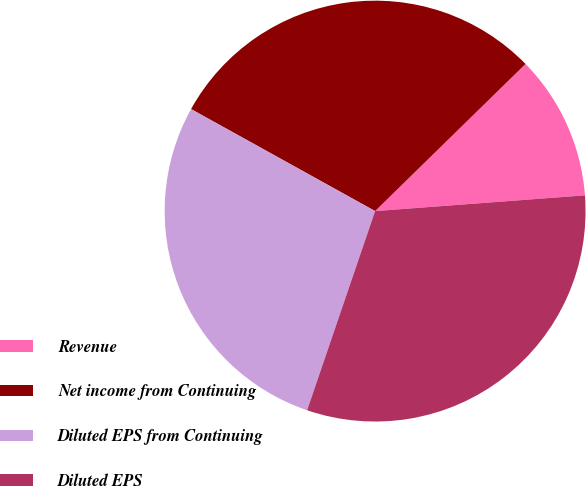<chart> <loc_0><loc_0><loc_500><loc_500><pie_chart><fcel>Revenue<fcel>Net income from Continuing<fcel>Diluted EPS from Continuing<fcel>Diluted EPS<nl><fcel>11.13%<fcel>29.62%<fcel>27.82%<fcel>31.43%<nl></chart> 